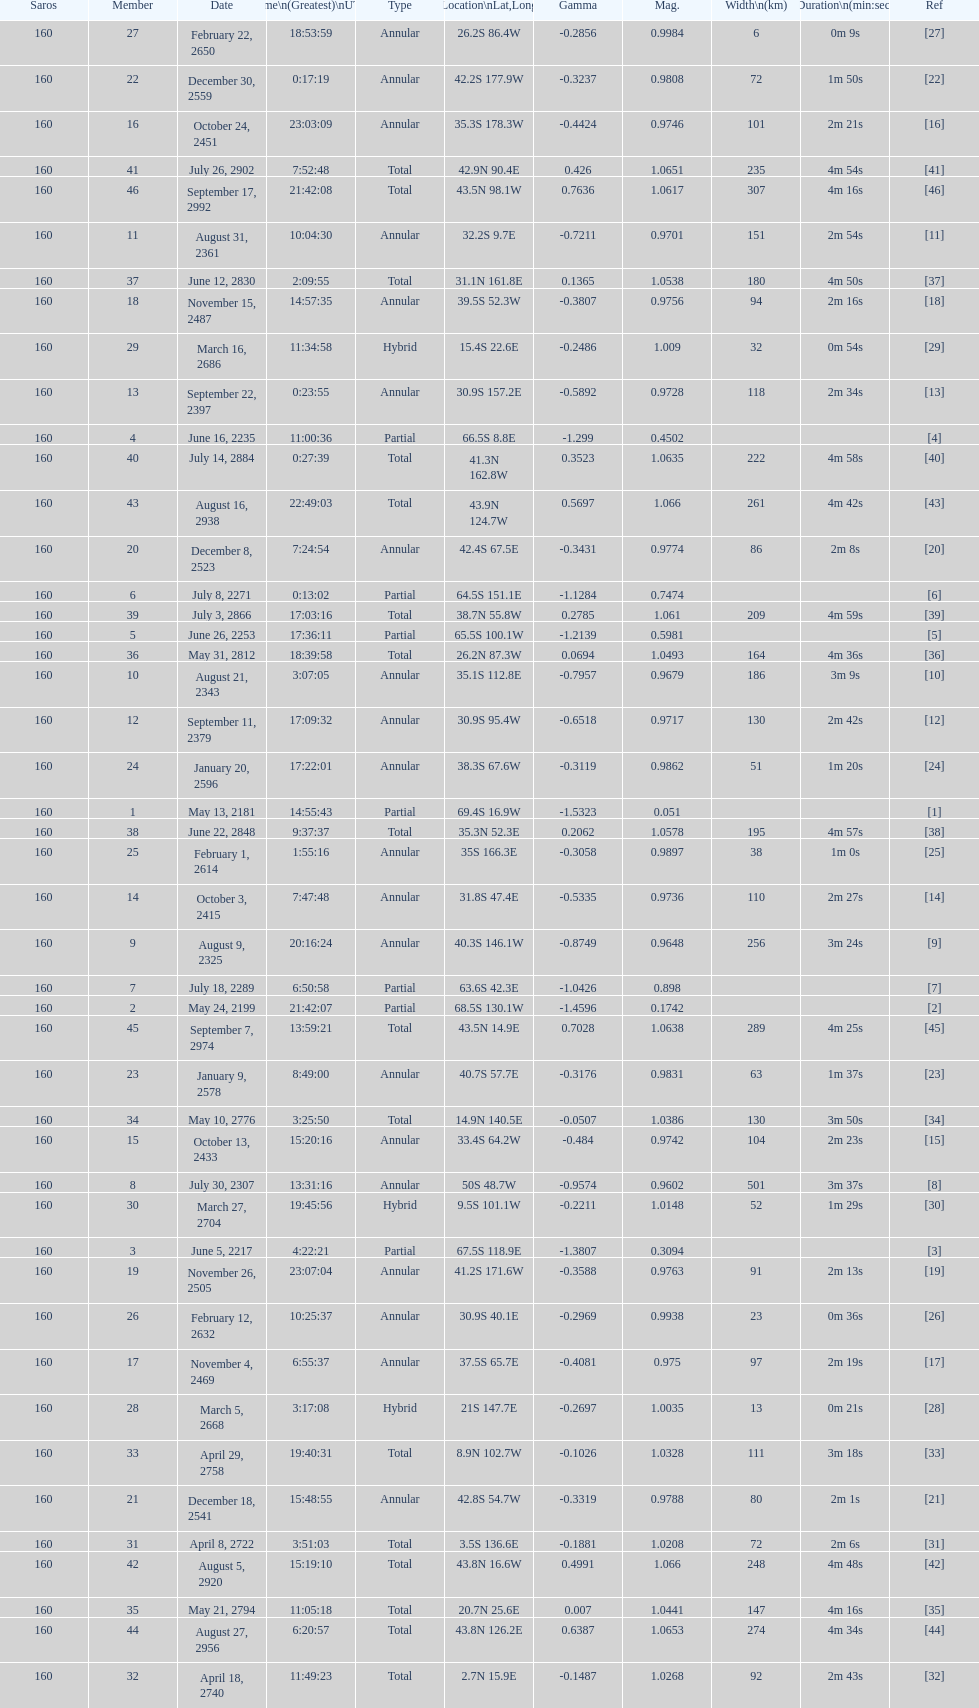How many partial members will occur before the first annular? 7. Would you be able to parse every entry in this table? {'header': ['Saros', 'Member', 'Date', 'Time\\n(Greatest)\\nUTC', 'Type', 'Location\\nLat,Long', 'Gamma', 'Mag.', 'Width\\n(km)', 'Duration\\n(min:sec)', 'Ref'], 'rows': [['160', '27', 'February 22, 2650', '18:53:59', 'Annular', '26.2S 86.4W', '-0.2856', '0.9984', '6', '0m 9s', '[27]'], ['160', '22', 'December 30, 2559', '0:17:19', 'Annular', '42.2S 177.9W', '-0.3237', '0.9808', '72', '1m 50s', '[22]'], ['160', '16', 'October 24, 2451', '23:03:09', 'Annular', '35.3S 178.3W', '-0.4424', '0.9746', '101', '2m 21s', '[16]'], ['160', '41', 'July 26, 2902', '7:52:48', 'Total', '42.9N 90.4E', '0.426', '1.0651', '235', '4m 54s', '[41]'], ['160', '46', 'September 17, 2992', '21:42:08', 'Total', '43.5N 98.1W', '0.7636', '1.0617', '307', '4m 16s', '[46]'], ['160', '11', 'August 31, 2361', '10:04:30', 'Annular', '32.2S 9.7E', '-0.7211', '0.9701', '151', '2m 54s', '[11]'], ['160', '37', 'June 12, 2830', '2:09:55', 'Total', '31.1N 161.8E', '0.1365', '1.0538', '180', '4m 50s', '[37]'], ['160', '18', 'November 15, 2487', '14:57:35', 'Annular', '39.5S 52.3W', '-0.3807', '0.9756', '94', '2m 16s', '[18]'], ['160', '29', 'March 16, 2686', '11:34:58', 'Hybrid', '15.4S 22.6E', '-0.2486', '1.009', '32', '0m 54s', '[29]'], ['160', '13', 'September 22, 2397', '0:23:55', 'Annular', '30.9S 157.2E', '-0.5892', '0.9728', '118', '2m 34s', '[13]'], ['160', '4', 'June 16, 2235', '11:00:36', 'Partial', '66.5S 8.8E', '-1.299', '0.4502', '', '', '[4]'], ['160', '40', 'July 14, 2884', '0:27:39', 'Total', '41.3N 162.8W', '0.3523', '1.0635', '222', '4m 58s', '[40]'], ['160', '43', 'August 16, 2938', '22:49:03', 'Total', '43.9N 124.7W', '0.5697', '1.066', '261', '4m 42s', '[43]'], ['160', '20', 'December 8, 2523', '7:24:54', 'Annular', '42.4S 67.5E', '-0.3431', '0.9774', '86', '2m 8s', '[20]'], ['160', '6', 'July 8, 2271', '0:13:02', 'Partial', '64.5S 151.1E', '-1.1284', '0.7474', '', '', '[6]'], ['160', '39', 'July 3, 2866', '17:03:16', 'Total', '38.7N 55.8W', '0.2785', '1.061', '209', '4m 59s', '[39]'], ['160', '5', 'June 26, 2253', '17:36:11', 'Partial', '65.5S 100.1W', '-1.2139', '0.5981', '', '', '[5]'], ['160', '36', 'May 31, 2812', '18:39:58', 'Total', '26.2N 87.3W', '0.0694', '1.0493', '164', '4m 36s', '[36]'], ['160', '10', 'August 21, 2343', '3:07:05', 'Annular', '35.1S 112.8E', '-0.7957', '0.9679', '186', '3m 9s', '[10]'], ['160', '12', 'September 11, 2379', '17:09:32', 'Annular', '30.9S 95.4W', '-0.6518', '0.9717', '130', '2m 42s', '[12]'], ['160', '24', 'January 20, 2596', '17:22:01', 'Annular', '38.3S 67.6W', '-0.3119', '0.9862', '51', '1m 20s', '[24]'], ['160', '1', 'May 13, 2181', '14:55:43', 'Partial', '69.4S 16.9W', '-1.5323', '0.051', '', '', '[1]'], ['160', '38', 'June 22, 2848', '9:37:37', 'Total', '35.3N 52.3E', '0.2062', '1.0578', '195', '4m 57s', '[38]'], ['160', '25', 'February 1, 2614', '1:55:16', 'Annular', '35S 166.3E', '-0.3058', '0.9897', '38', '1m 0s', '[25]'], ['160', '14', 'October 3, 2415', '7:47:48', 'Annular', '31.8S 47.4E', '-0.5335', '0.9736', '110', '2m 27s', '[14]'], ['160', '9', 'August 9, 2325', '20:16:24', 'Annular', '40.3S 146.1W', '-0.8749', '0.9648', '256', '3m 24s', '[9]'], ['160', '7', 'July 18, 2289', '6:50:58', 'Partial', '63.6S 42.3E', '-1.0426', '0.898', '', '', '[7]'], ['160', '2', 'May 24, 2199', '21:42:07', 'Partial', '68.5S 130.1W', '-1.4596', '0.1742', '', '', '[2]'], ['160', '45', 'September 7, 2974', '13:59:21', 'Total', '43.5N 14.9E', '0.7028', '1.0638', '289', '4m 25s', '[45]'], ['160', '23', 'January 9, 2578', '8:49:00', 'Annular', '40.7S 57.7E', '-0.3176', '0.9831', '63', '1m 37s', '[23]'], ['160', '34', 'May 10, 2776', '3:25:50', 'Total', '14.9N 140.5E', '-0.0507', '1.0386', '130', '3m 50s', '[34]'], ['160', '15', 'October 13, 2433', '15:20:16', 'Annular', '33.4S 64.2W', '-0.484', '0.9742', '104', '2m 23s', '[15]'], ['160', '8', 'July 30, 2307', '13:31:16', 'Annular', '50S 48.7W', '-0.9574', '0.9602', '501', '3m 37s', '[8]'], ['160', '30', 'March 27, 2704', '19:45:56', 'Hybrid', '9.5S 101.1W', '-0.2211', '1.0148', '52', '1m 29s', '[30]'], ['160', '3', 'June 5, 2217', '4:22:21', 'Partial', '67.5S 118.9E', '-1.3807', '0.3094', '', '', '[3]'], ['160', '19', 'November 26, 2505', '23:07:04', 'Annular', '41.2S 171.6W', '-0.3588', '0.9763', '91', '2m 13s', '[19]'], ['160', '26', 'February 12, 2632', '10:25:37', 'Annular', '30.9S 40.1E', '-0.2969', '0.9938', '23', '0m 36s', '[26]'], ['160', '17', 'November 4, 2469', '6:55:37', 'Annular', '37.5S 65.7E', '-0.4081', '0.975', '97', '2m 19s', '[17]'], ['160', '28', 'March 5, 2668', '3:17:08', 'Hybrid', '21S 147.7E', '-0.2697', '1.0035', '13', '0m 21s', '[28]'], ['160', '33', 'April 29, 2758', '19:40:31', 'Total', '8.9N 102.7W', '-0.1026', '1.0328', '111', '3m 18s', '[33]'], ['160', '21', 'December 18, 2541', '15:48:55', 'Annular', '42.8S 54.7W', '-0.3319', '0.9788', '80', '2m 1s', '[21]'], ['160', '31', 'April 8, 2722', '3:51:03', 'Total', '3.5S 136.6E', '-0.1881', '1.0208', '72', '2m 6s', '[31]'], ['160', '42', 'August 5, 2920', '15:19:10', 'Total', '43.8N 16.6W', '0.4991', '1.066', '248', '4m 48s', '[42]'], ['160', '35', 'May 21, 2794', '11:05:18', 'Total', '20.7N 25.6E', '0.007', '1.0441', '147', '4m 16s', '[35]'], ['160', '44', 'August 27, 2956', '6:20:57', 'Total', '43.8N 126.2E', '0.6387', '1.0653', '274', '4m 34s', '[44]'], ['160', '32', 'April 18, 2740', '11:49:23', 'Total', '2.7N 15.9E', '-0.1487', '1.0268', '92', '2m 43s', '[32]']]} 